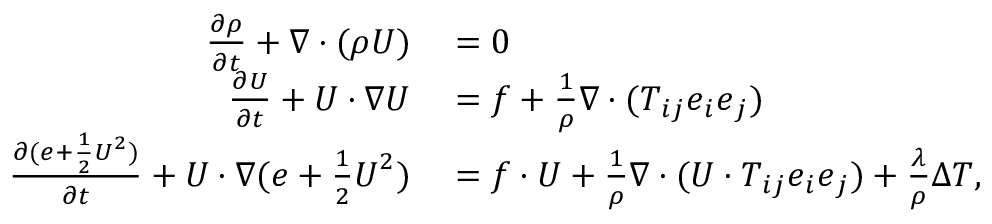Convert formula to latex. <formula><loc_0><loc_0><loc_500><loc_500>\begin{array} { r l } { \frac { \partial \rho } { \partial t } + \nabla \cdot ( \rho U ) } & = 0 } \\ { \frac { \partial U } { \partial t } + U \cdot \nabla U } & = f + \frac { 1 } { \rho } \nabla \cdot ( T _ { i j } e _ { i } e _ { j } ) } \\ { \frac { \partial ( e + \frac { 1 } { 2 } U ^ { 2 } ) } { \partial t } + U \cdot \nabla ( e + \frac { 1 } { 2 } U ^ { 2 } ) } & = f \cdot U + \frac { 1 } { \rho } \nabla \cdot ( U \cdot T _ { i j } e _ { i } e _ { j } ) + \frac { \lambda } { \rho } \Delta T , } \end{array}</formula> 